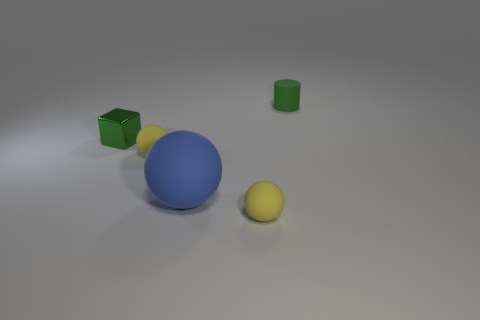Add 4 yellow matte spheres. How many objects exist? 9 Subtract all spheres. How many objects are left? 2 Subtract 0 blue blocks. How many objects are left? 5 Subtract all blue objects. Subtract all small rubber cylinders. How many objects are left? 3 Add 4 small green objects. How many small green objects are left? 6 Add 3 big blue objects. How many big blue objects exist? 4 